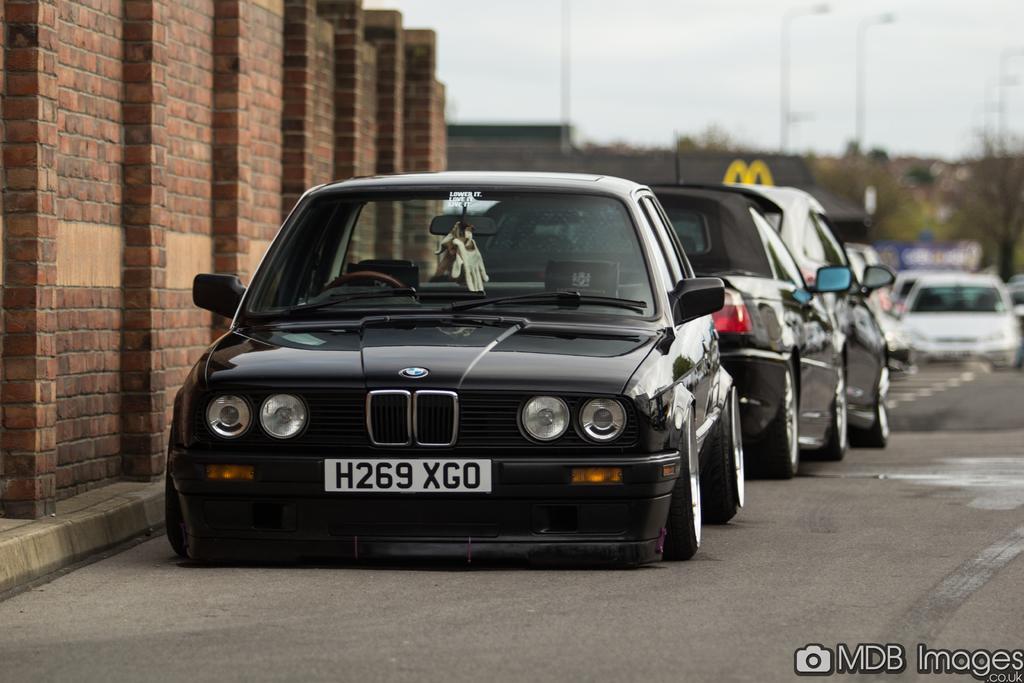Describe this image in one or two sentences. In this picture there are cars in series in the center of the image and there is a wall on the left side of the image, there are poles and trees in the background area of the image. 